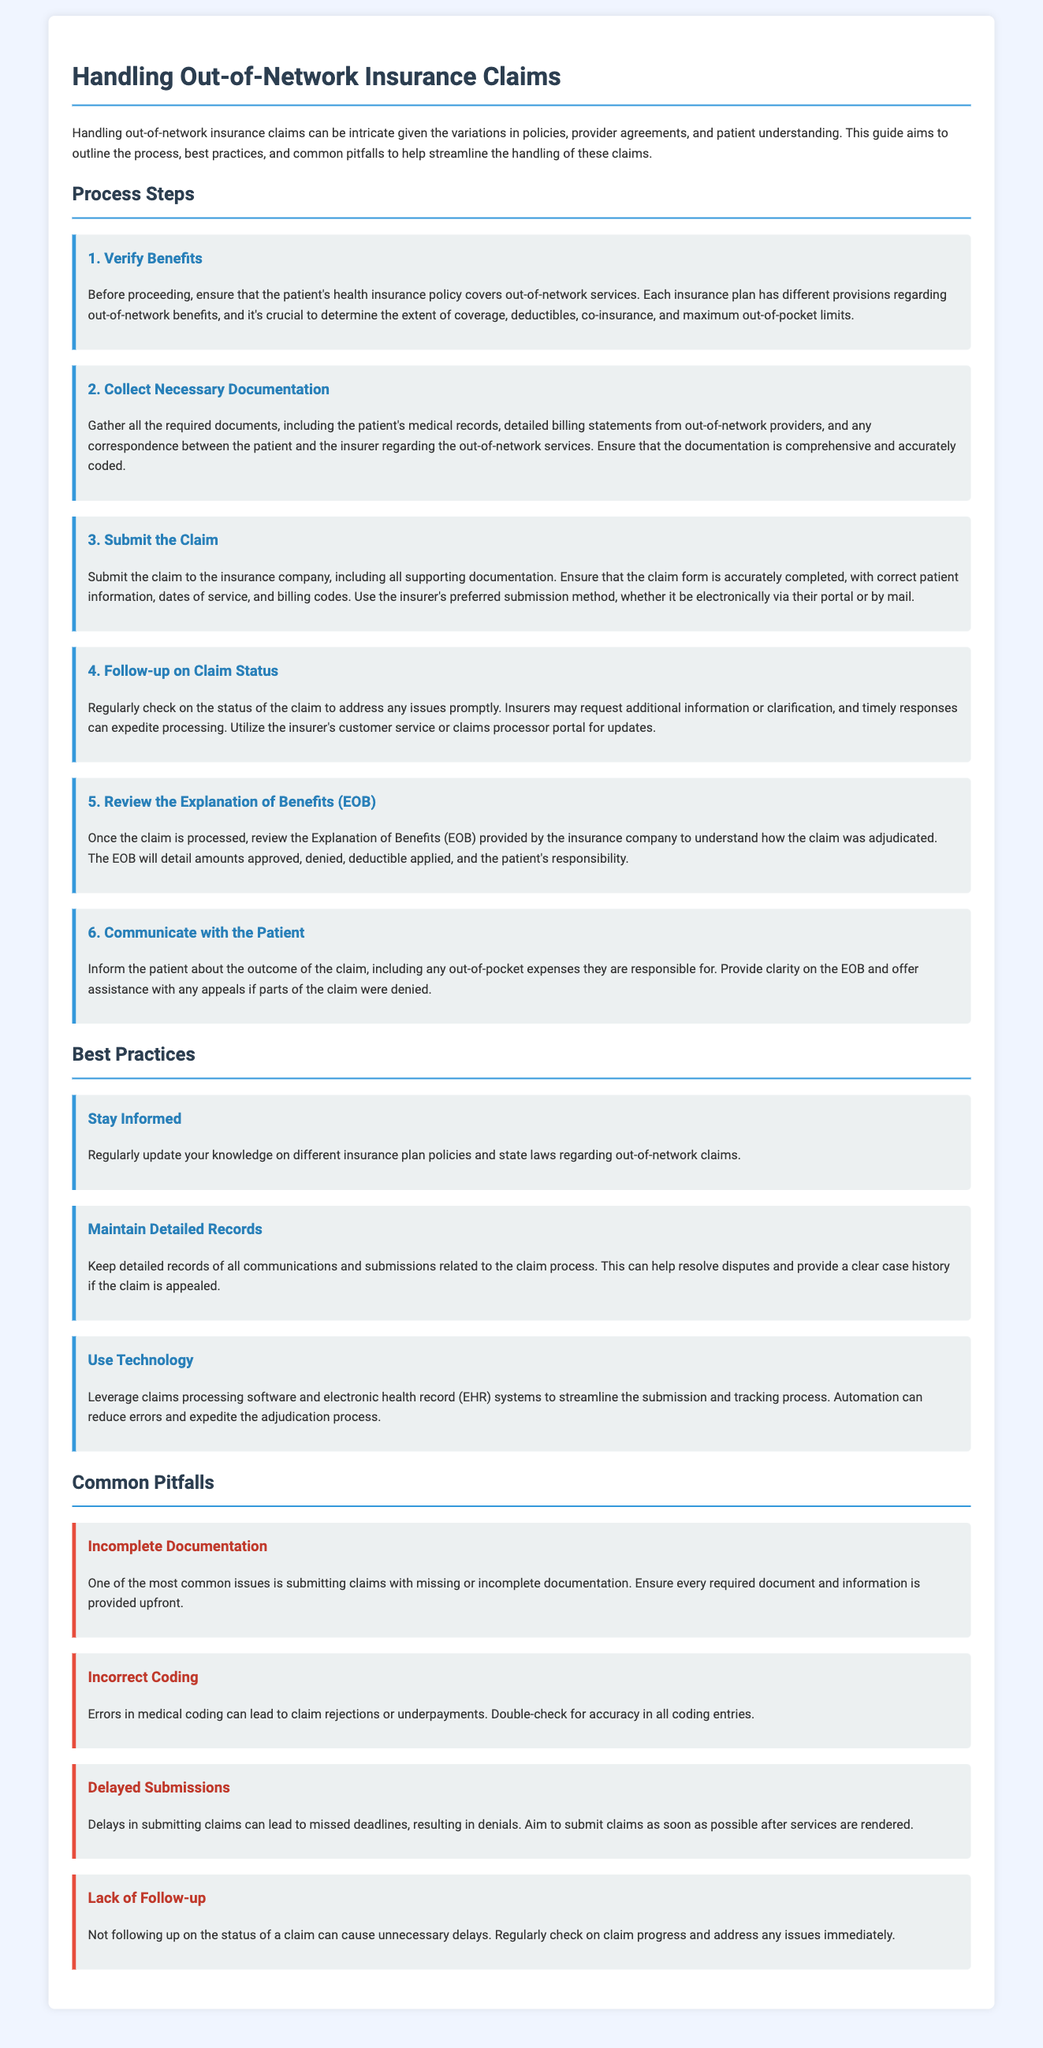what is the first step in handling out-of-network insurance claims? The first step in the process is verifying the patient's health insurance benefits regarding out-of-network services.
Answer: Verify Benefits how many steps are involved in the claims process? The document outlines a total of six steps involved in the claims process.
Answer: Six what should be included in the claim submission? The claim submission should include all supporting documentation, accurate patient information, dates of service, and billing codes.
Answer: Supporting documentation what common pitfall is related to documentation? One common pitfall is submitting claims with missing or incomplete documentation.
Answer: Incomplete Documentation which best practice involves using technology? The best practice related to technology is leveraging claims processing software and electronic health record (EHR) systems.
Answer: Use Technology what is the potential consequence of incorrect coding? Errors in medical coding can lead to claim rejections or underpayments.
Answer: Claim rejections how can one stay updated on insurance policies? Regularly updating knowledge on different insurance plan policies and state laws helps in staying informed.
Answer: Stay Informed what should be done after receiving the Explanation of Benefits (EOB)? After receiving the EOB, one should review it to understand how the claim was adjudicated.
Answer: Review the EOB what is a key aspect of communication with the patient? It's important to inform the patient about the outcome of the claim and any out-of-pocket expenses.
Answer: Communicate with the Patient 